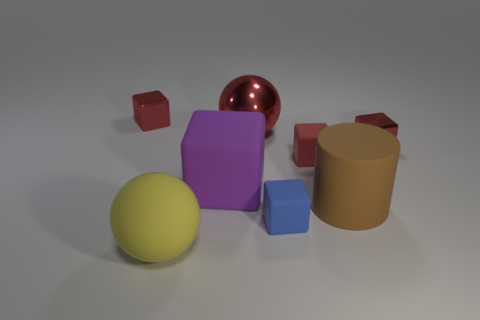Are there an equal number of big yellow objects behind the purple matte object and matte balls?
Give a very brief answer. No. How many other objects are the same shape as the purple object?
Provide a succinct answer. 4. What number of things are left of the big red metallic ball?
Give a very brief answer. 3. There is a thing that is both in front of the cylinder and on the right side of the large purple object; what is its size?
Your response must be concise. Small. Are any tiny brown rubber balls visible?
Offer a very short reply. No. What number of other objects are the same size as the brown cylinder?
Your answer should be compact. 3. There is a big sphere that is behind the tiny red rubber block; is its color the same as the big rubber thing that is in front of the matte cylinder?
Offer a terse response. No. What is the size of the red matte object that is the same shape as the purple matte thing?
Provide a succinct answer. Small. Are the ball in front of the big brown matte cylinder and the sphere behind the big matte ball made of the same material?
Offer a terse response. No. How many matte things are either small red blocks or balls?
Your response must be concise. 2. 